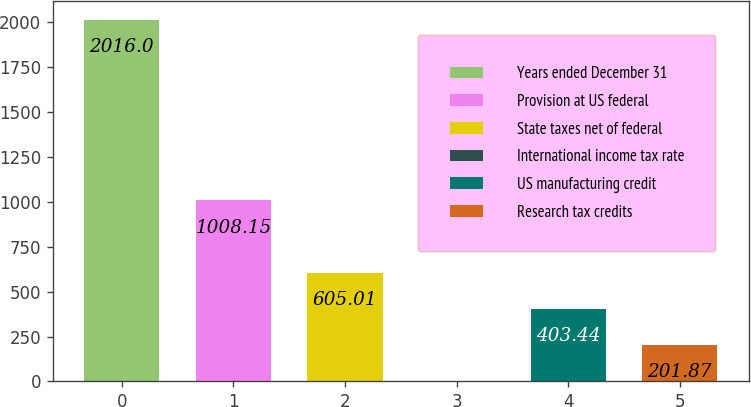Convert chart to OTSL. <chart><loc_0><loc_0><loc_500><loc_500><bar_chart><fcel>Years ended December 31<fcel>Provision at US federal<fcel>State taxes net of federal<fcel>International income tax rate<fcel>US manufacturing credit<fcel>Research tax credits<nl><fcel>2016<fcel>1008.15<fcel>605.01<fcel>0.3<fcel>403.44<fcel>201.87<nl></chart> 